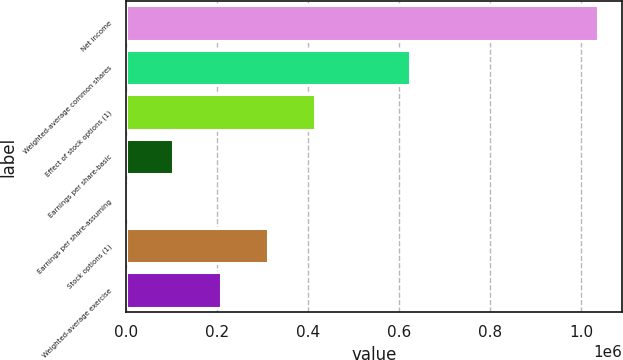<chart> <loc_0><loc_0><loc_500><loc_500><bar_chart><fcel>Net income<fcel>Weighted-average common shares<fcel>Effect of stock options (1)<fcel>Earnings per share-basic<fcel>Earnings per share-assuming<fcel>Stock options (1)<fcel>Weighted-average exercise<nl><fcel>1.03769e+06<fcel>622619<fcel>415083<fcel>103779<fcel>10.73<fcel>311315<fcel>207547<nl></chart> 